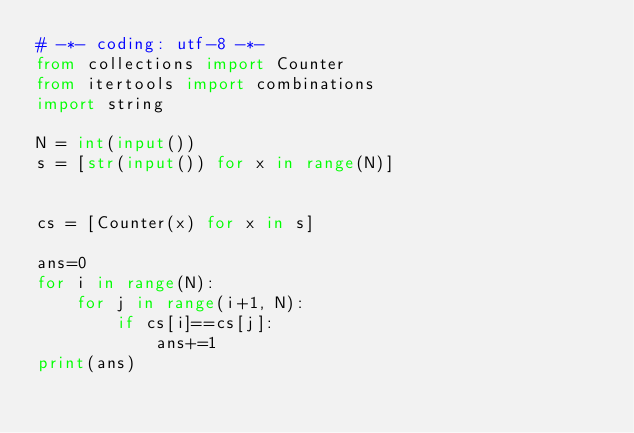Convert code to text. <code><loc_0><loc_0><loc_500><loc_500><_Python_># -*- coding: utf-8 -*-
from collections import Counter
from itertools import combinations
import string

N = int(input())
s = [str(input()) for x in range(N)]


cs = [Counter(x) for x in s]

ans=0
for i in range(N):
    for j in range(i+1, N):
        if cs[i]==cs[j]:
            ans+=1
print(ans)</code> 